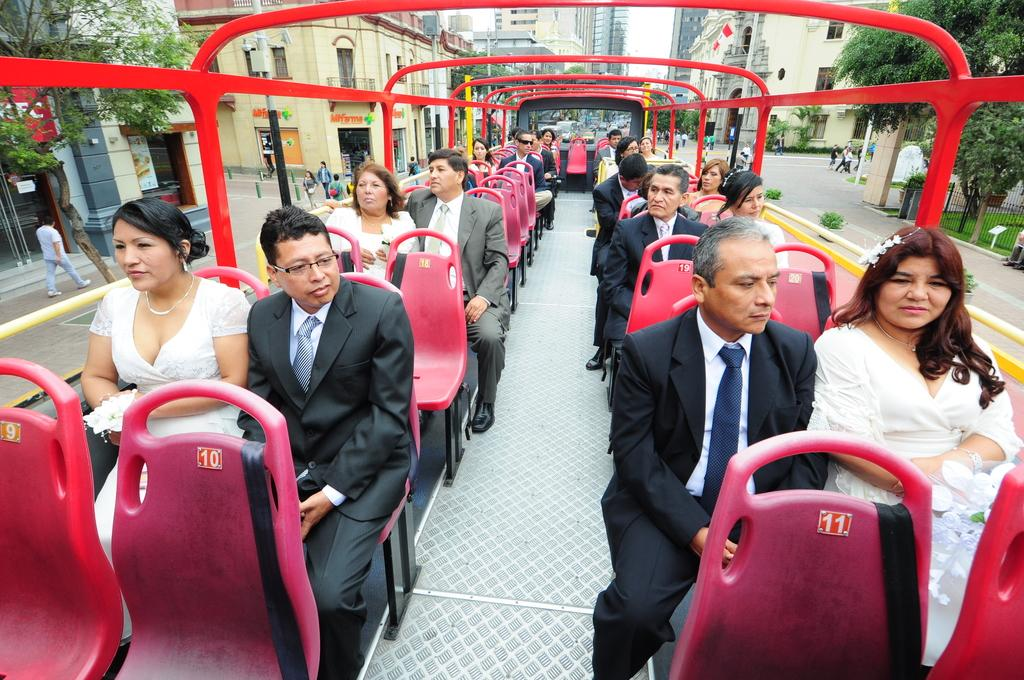<image>
Provide a brief description of the given image. A group of people on a sightseeing bus with numbered pink seats, in front of a building called Myfirma. 